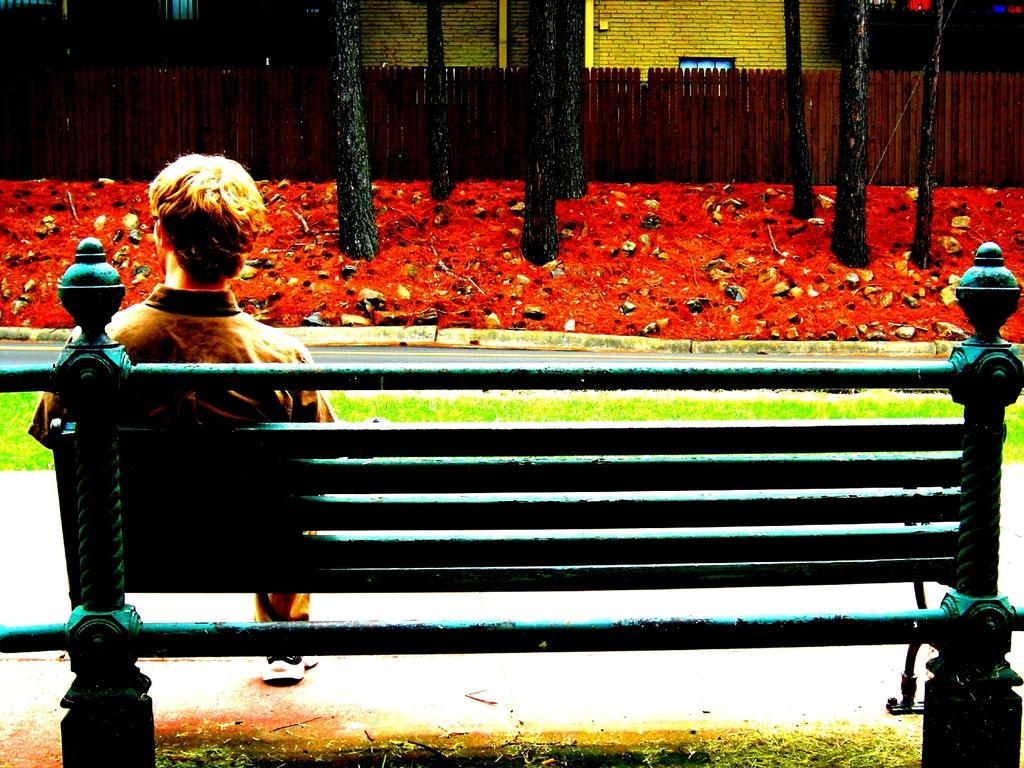Where was the image taken? The image was clicked outside. What is the person in the foreground doing? The person is sitting on a bench in the foreground. What can be seen in the background of the image? There is a wooden fence, buildings, and tree trunks visible in the background. What type of grape is growing on the tree trunks in the image? There are no grapes or trees growing grapes present in the image; only tree trunks are visible. 